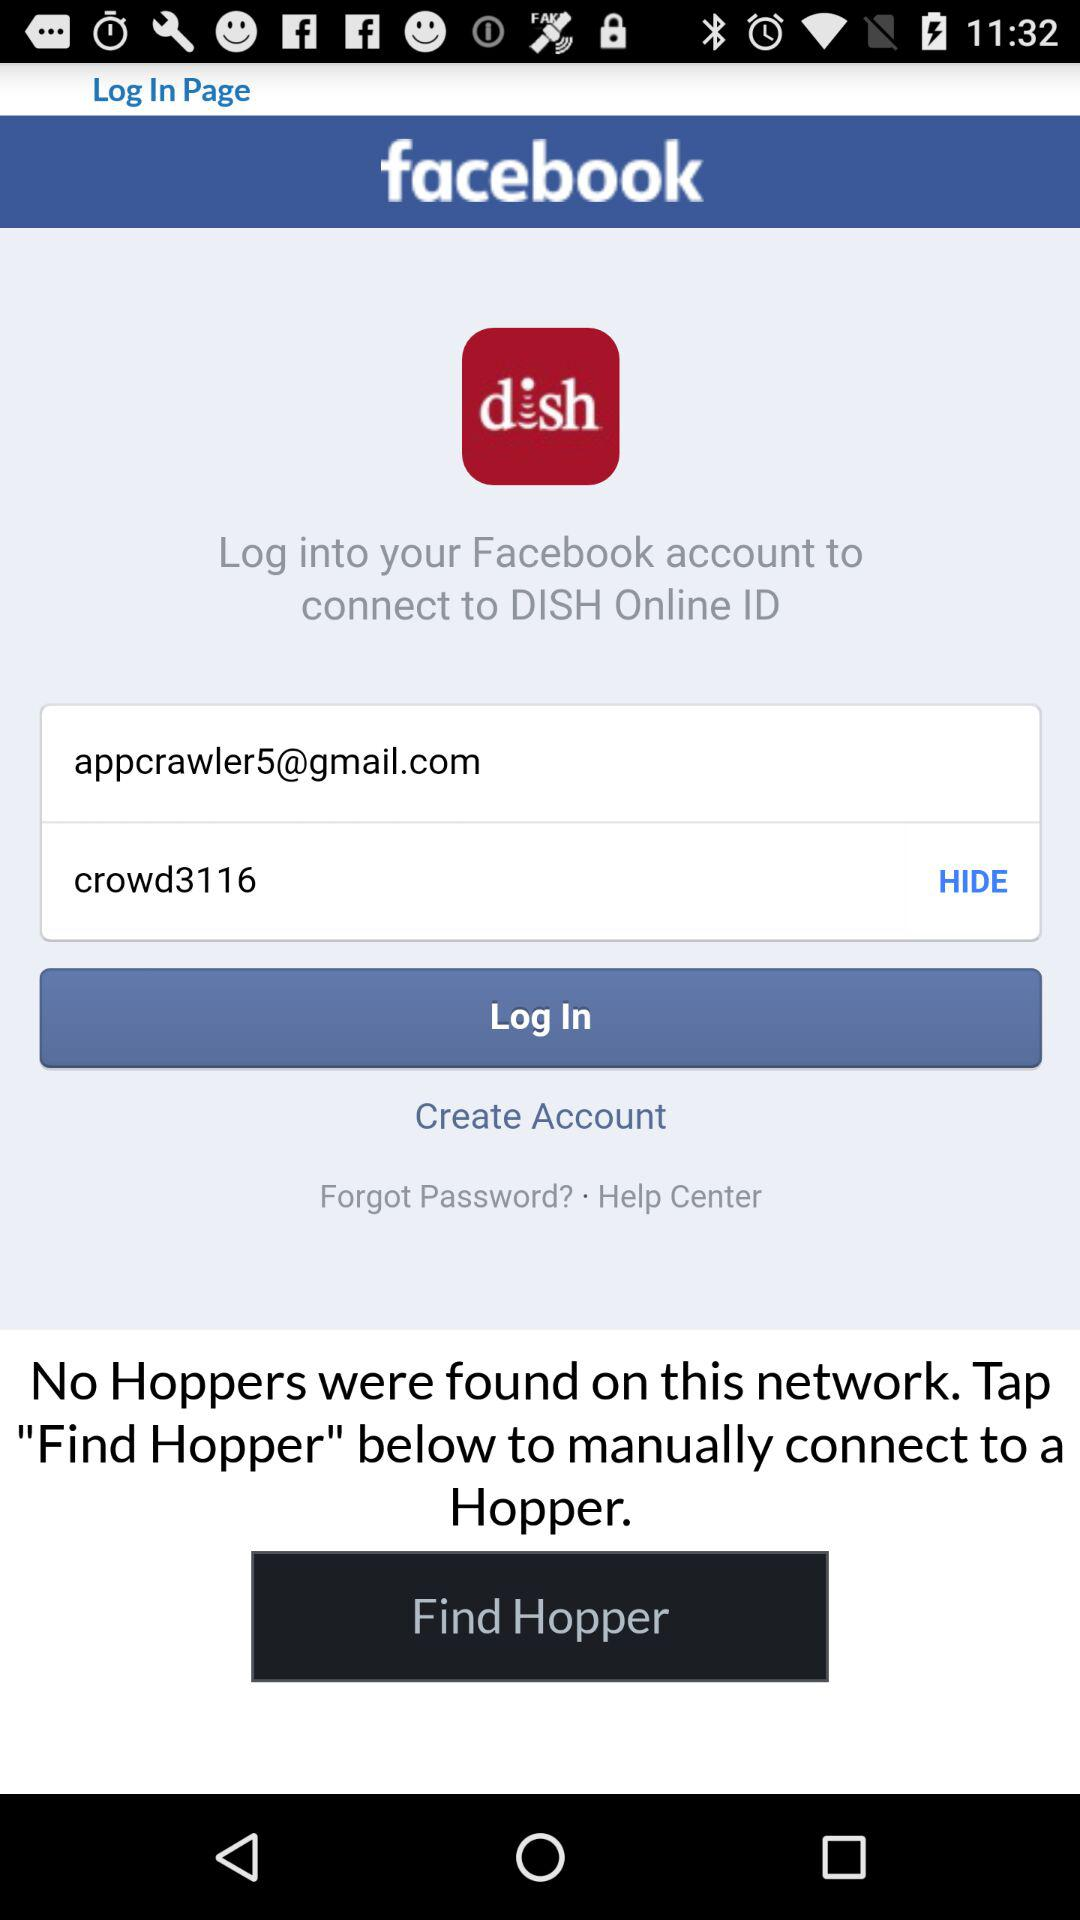What is the password? The password is crowd3116. 